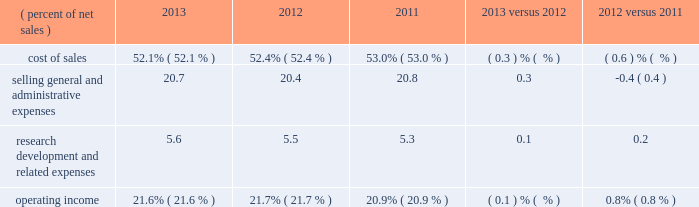Operating expenses : 2013 versus 2012 versus ( percent of net sales ) 2013 2012 2011 .
Pension and postretirement expense decreased $ 97 million in 2013 compared to 2012 , compared to an increase of $ 95 million for 2012 compared to 2011 .
2012 includes a $ 26 million charge related to the first-quarter 2012 voluntary early retirement incentive program ( discussed in note 10 ) .
Pension and postretirement expense is recorded in cost of sales ; selling , general and administrative expenses ( sg&a ) ; and research , development and related expenses ( r&d ) .
Refer to note 10 ( pension and postretirement plans ) for components of net periodic benefit cost and the assumptions used to determine net cost .
Cost of sales : cost of sales includes manufacturing , engineering and freight costs .
Cost of sales , measured as a percent of net sales , was 52.1 percent in 2013 , a decrease of 0.3 percentage points from 2012 .
Cost of sales as a percent of sales decreased due to the combination of selling price increases and raw material cost decreases , as selling prices rose 0.9 percent and raw material cost deflation was approximately 2 percent favorable year-on-year .
In addition , lower pension and postretirement costs ( of which a portion impacts cost of sales ) , in addition to organic volume increases , decreased cost of sales as a percent of sales .
These benefits were partially offset by the impact of 2012 acquisitions and lower factory utilization .
Cost of sales , measured as a percent of net sales , was 52.4 percent in 2012 , a decrease of 0.6 percentage points from 2011 .
The net impact of selling price/raw material cost changes was the primary factor that decreased cost of sales as a percent of sales , as selling prices increased 1.4 percent and raw material costs decreased approximately 2 percent .
This benefit was partially offset by higher pension and postretirement costs .
Selling , general and administrative expenses : selling , general and administrative expenses ( sg&a ) increased $ 282 million , or 4.6 percent , in 2013 when compared to 2012 .
In 2013 , sg&a included strategic investments in business transformation , enabled by 3m 2019s global enterprise resource planning ( erp ) implementation , in addition to increases from acquired businesses that were largely not in 3m 2019s 2012 spending ( ceradyne , inc .
And federal signal technologies ) , which were partially offset by lower pension and postretirement expense .
Sg&a , measured as a percent of sales , increased 0.3 percentage points to 20.7 percent in 2013 , compared to 20.4 percent in 2012 .
Sg&a decreased $ 68 million , or 1.1 percent , in 2012 when compared to 2011 .
In addition to cost-control and other productivity efforts , 3m experienced some savings from its first-quarter 2012 voluntary early retirement incentive program and other restructuring actions .
These benefits more than offset increases related to acquisitions , higher year-on-year pension and postretirement expense , and restructuring expenses .
Sg&a in 2012 included increases from acquired businesses which were not in 3m 2019s full-year 2011 base spending , primarily related to the 2011 acquisitions of winterthur technologie ag and the do-it-yourself and professional business of gpi group , in addition to sg&a spending related to the 2012 acquisitions of ceradyne , inc. , federal signal technologies group , and coderyte , inc .
Sg&a , measured as a percent of sales , was 20.4 percent in 2012 , a decrease of 0.4 percentage points when compared to 2011 .
Research , development and related expenses : research , development and related expenses ( r&d ) increased 4.9 percent in 2013 compared to 2012 and increased 4.1 percent in 2012 compared to 2011 , as 3m continued to support its key growth initiatives , including more r&d aimed at disruptive innovation .
In 2013 , increases from acquired businesses that were largely not in 3m 2019s 2012 spending ( primarily ceradyne , inc .
And federal signal technologies ) were partially offset by lower pension and postretirement expense .
In 2012 , investments to support key growth initiatives , along with higher pension and postretirement expense , were partially .
In 2013 what was the ratio of the selling general and administrative expenses to the research development and related expenses? 
Rationale: in 2013 the ratio of the selling general and administrative expenses to the research development and related expenses was 3.7 to 1
Computations: (20.7 / 5.6)
Answer: 3.69643. 